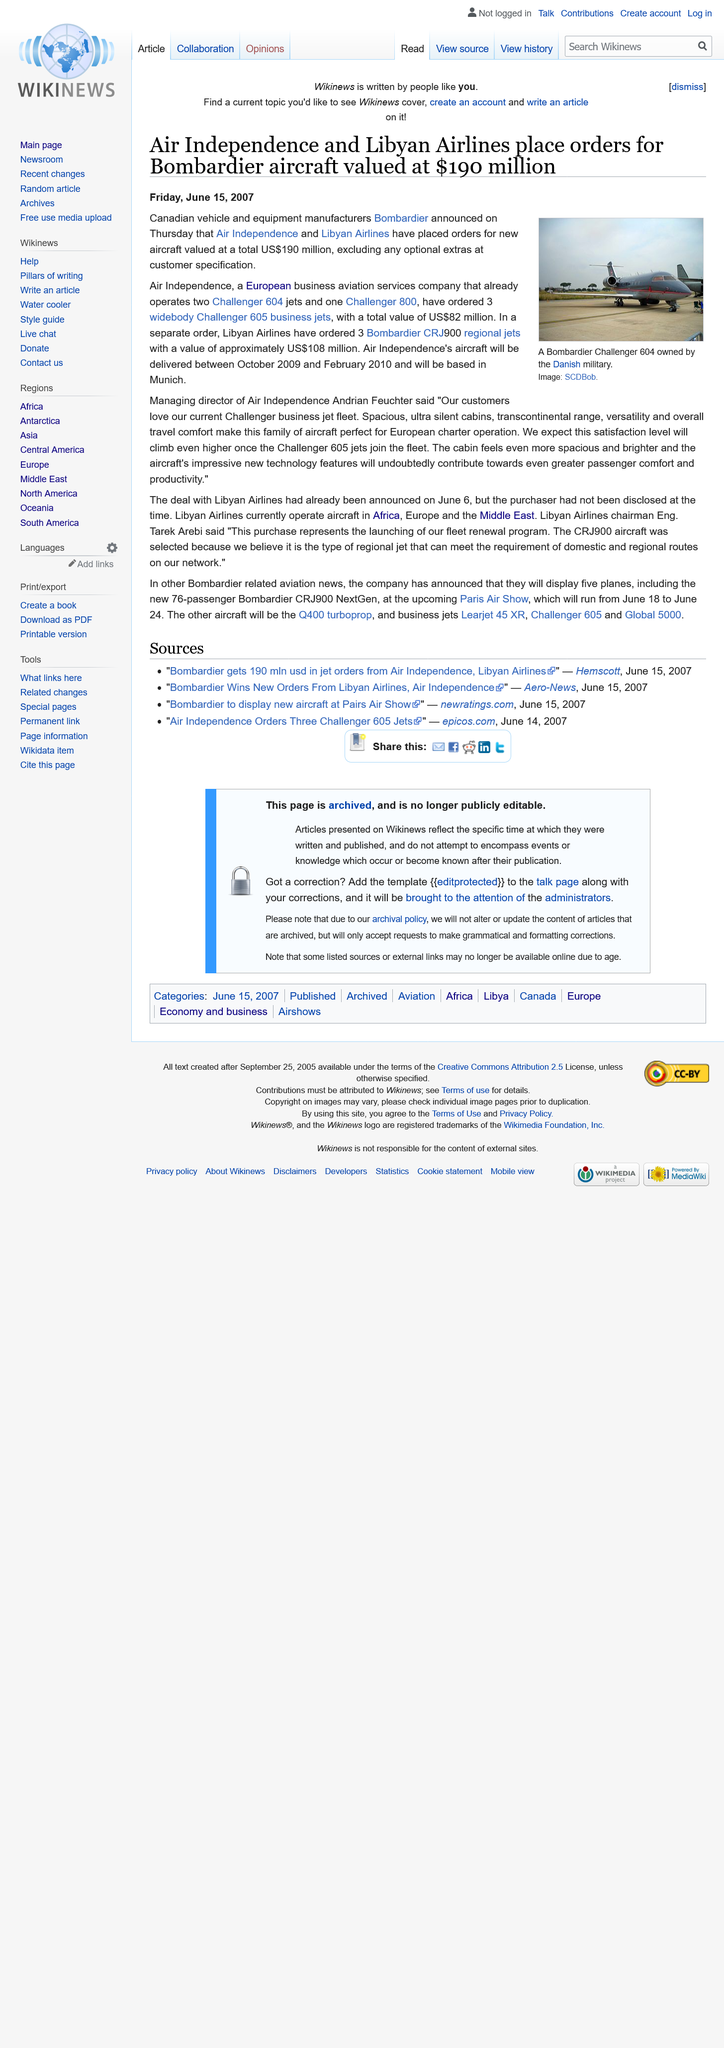Outline some significant characteristics in this image. On Thursday, June 14th 2007, Bombadier announced the order from Air Independence and Libyan Airlines, which was made prior to the writing of the article. The total value of the two orders is US$190 million. The Bombardier Challenger 604 is a type of aircraft that is pictured. 